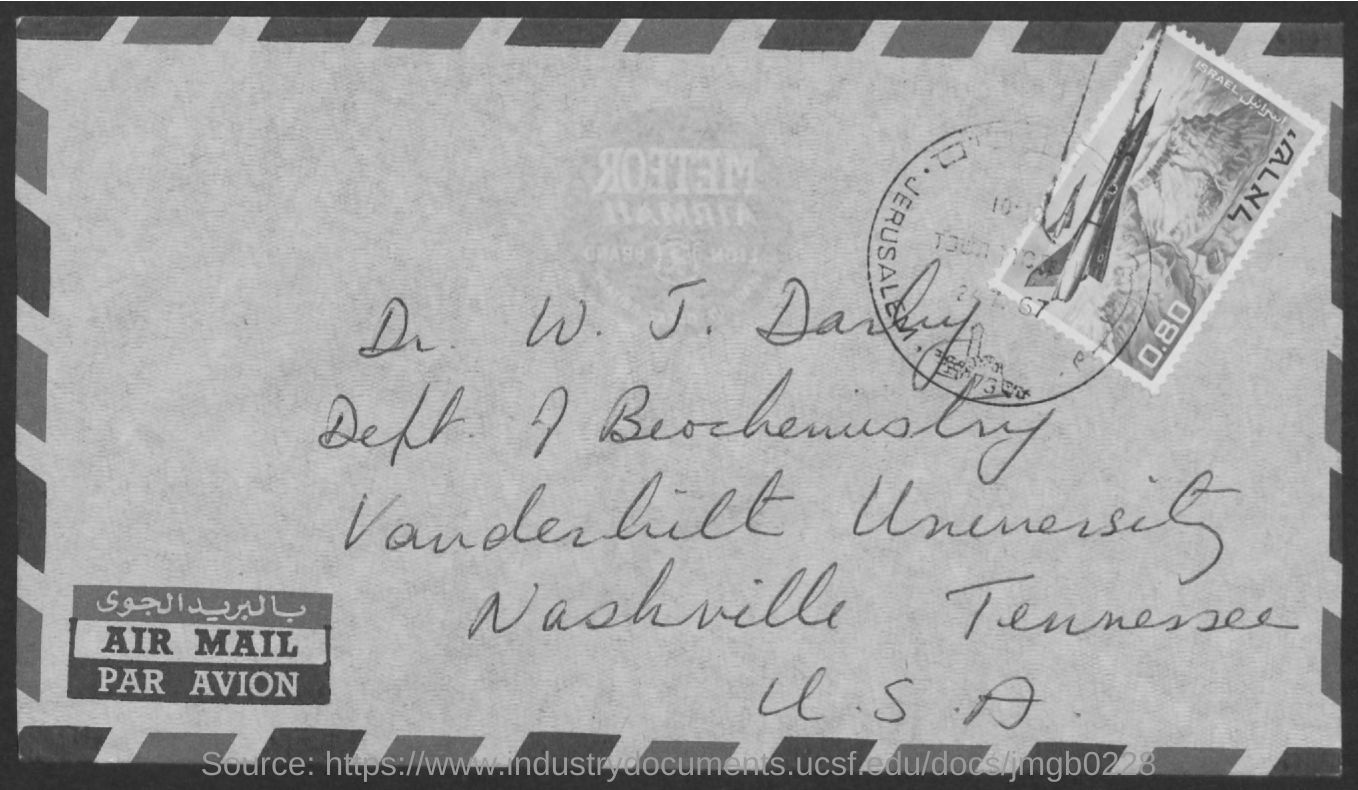Identify some key points in this picture. The person named in the address is Dr. W. J. Darby. 